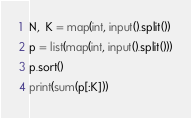<code> <loc_0><loc_0><loc_500><loc_500><_Python_>N,  K = map(int, input().split())
p = list(map(int, input().split()))
p.sort()
print(sum(p[:K]))</code> 